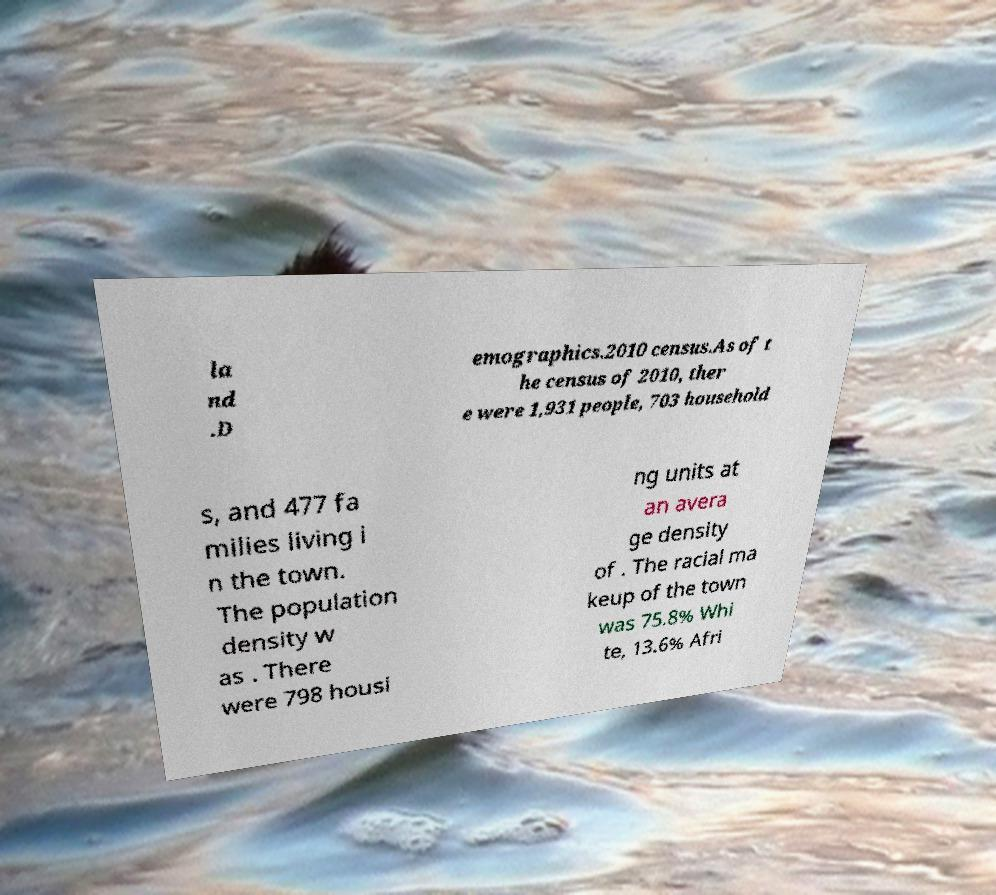Could you assist in decoding the text presented in this image and type it out clearly? la nd .D emographics.2010 census.As of t he census of 2010, ther e were 1,931 people, 703 household s, and 477 fa milies living i n the town. The population density w as . There were 798 housi ng units at an avera ge density of . The racial ma keup of the town was 75.8% Whi te, 13.6% Afri 